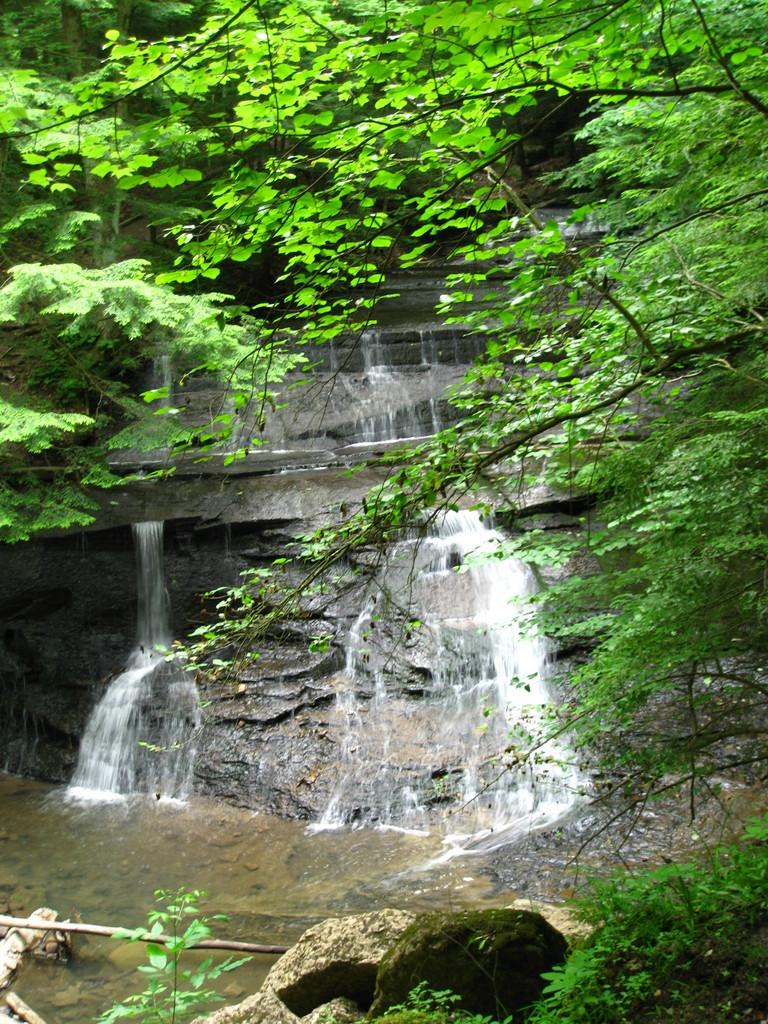What can be seen in the foreground of the image? There are trees, water, and rocks in the foreground of the image. What is located in the background of the image? There is a waterfall and trees in the background of the image. What type of natural environment is depicted in the image? The image features a combination of water, rocks, and trees, which suggests a natural setting such as a river or stream. Can you see any cheese in the image? There is no cheese present in the image. Is there an airplane flying over the waterfall in the image? There is no airplane visible in the image. 